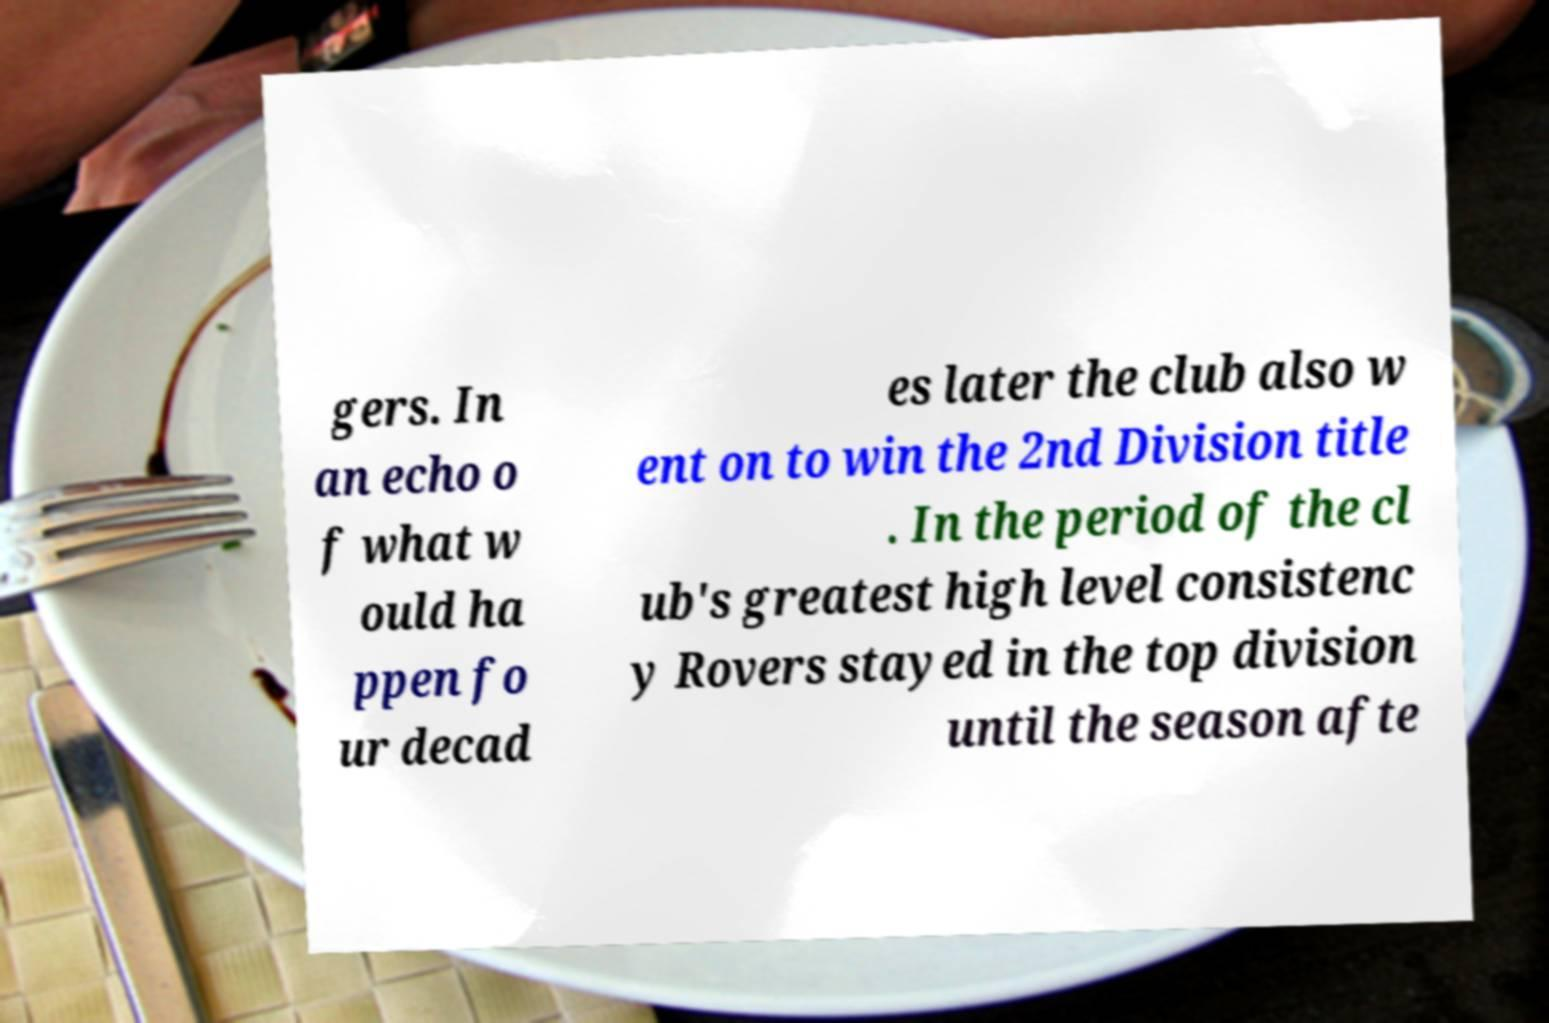Can you accurately transcribe the text from the provided image for me? gers. In an echo o f what w ould ha ppen fo ur decad es later the club also w ent on to win the 2nd Division title . In the period of the cl ub's greatest high level consistenc y Rovers stayed in the top division until the season afte 